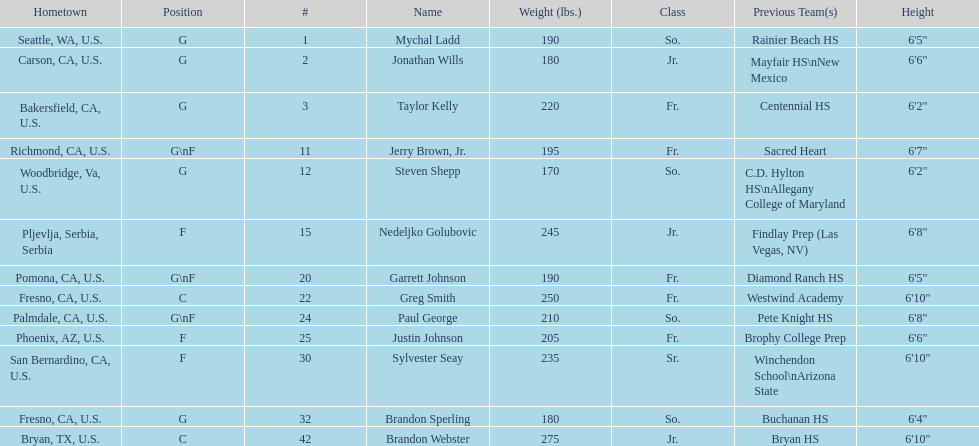Who is the next heaviest player after nedelijko golubovic? Sylvester Seay. 